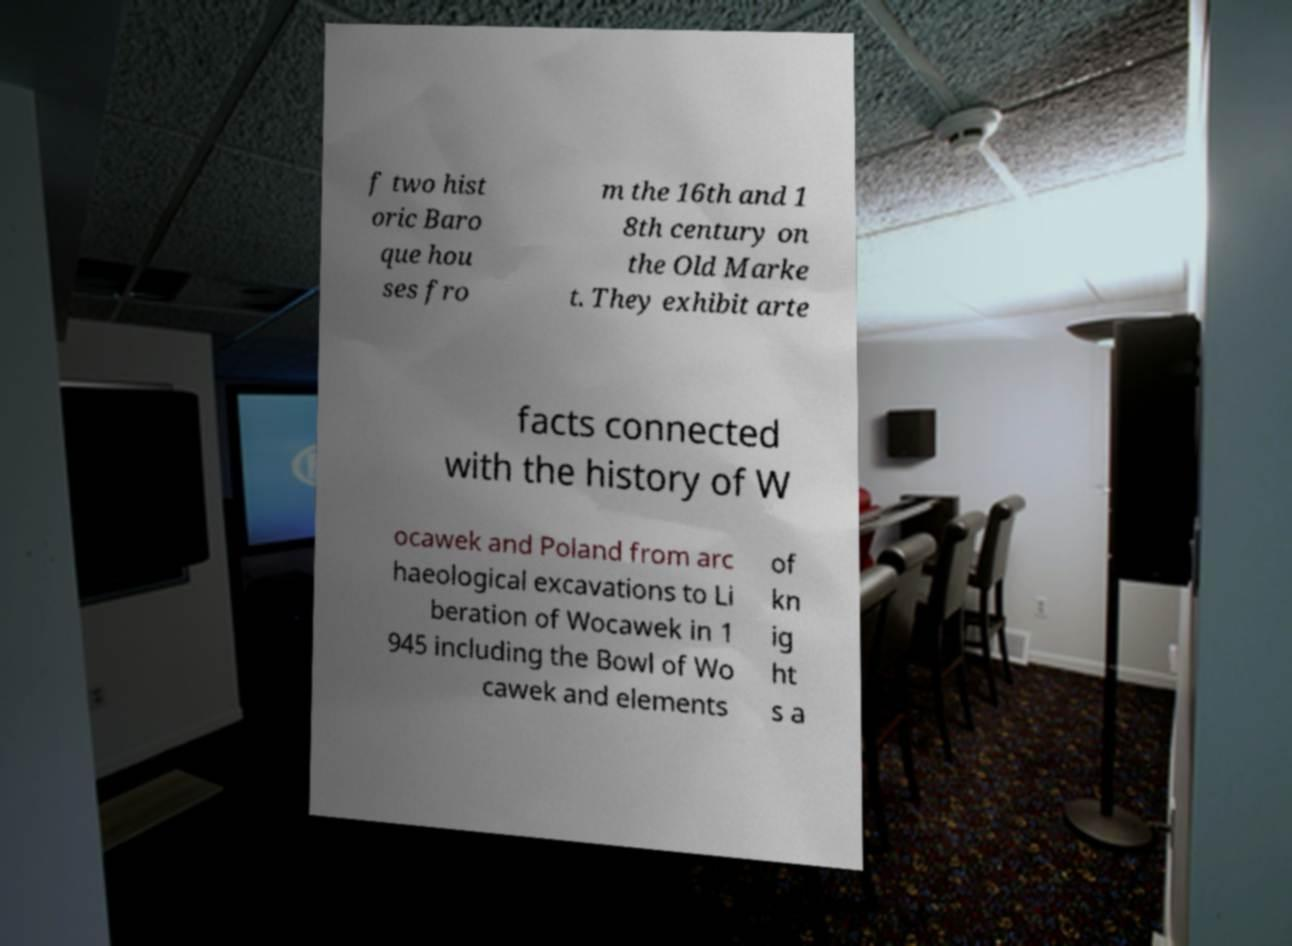Please identify and transcribe the text found in this image. f two hist oric Baro que hou ses fro m the 16th and 1 8th century on the Old Marke t. They exhibit arte facts connected with the history of W ocawek and Poland from arc haeological excavations to Li beration of Wocawek in 1 945 including the Bowl of Wo cawek and elements of kn ig ht s a 